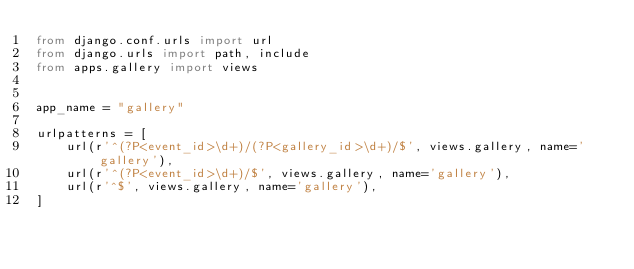Convert code to text. <code><loc_0><loc_0><loc_500><loc_500><_Python_>from django.conf.urls import url
from django.urls import path, include
from apps.gallery import views


app_name = "gallery"

urlpatterns = [
    url(r'^(?P<event_id>\d+)/(?P<gallery_id>\d+)/$', views.gallery, name='gallery'),
    url(r'^(?P<event_id>\d+)/$', views.gallery, name='gallery'),
    url(r'^$', views.gallery, name='gallery'),
]

</code> 